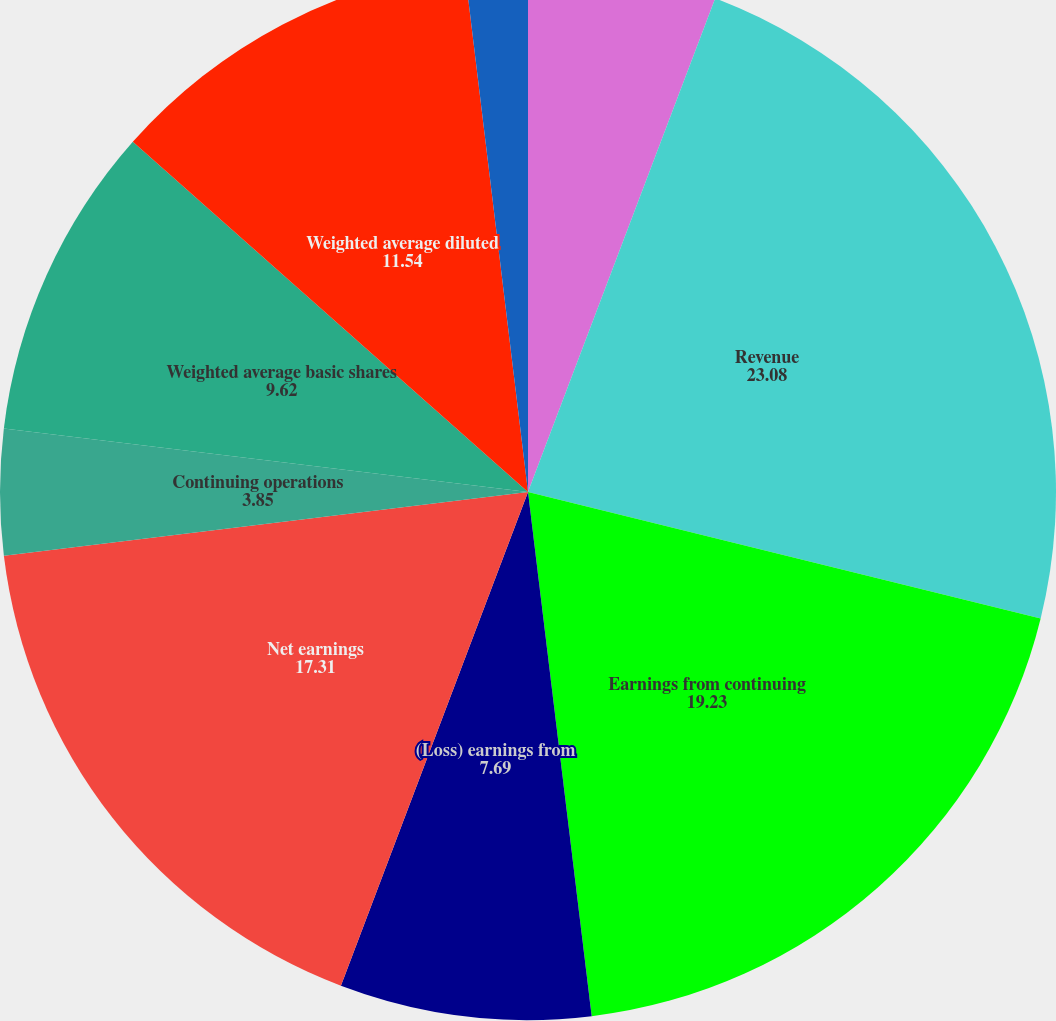<chart> <loc_0><loc_0><loc_500><loc_500><pie_chart><fcel>in thousands except per share<fcel>Revenue<fcel>Earnings from continuing<fcel>(Loss) earnings from<fcel>Net earnings<fcel>Continuing operations<fcel>Discontinued operations<fcel>Weighted average basic shares<fcel>Weighted average diluted<fcel>Dividends per common share<nl><fcel>5.77%<fcel>23.08%<fcel>19.23%<fcel>7.69%<fcel>17.31%<fcel>3.85%<fcel>0.0%<fcel>9.62%<fcel>11.54%<fcel>1.92%<nl></chart> 